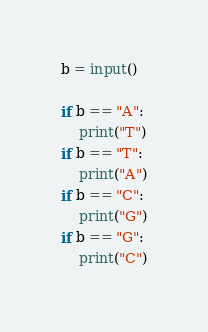<code> <loc_0><loc_0><loc_500><loc_500><_Python_>b = input()

if b == "A":
    print("T")
if b == "T":
    print("A")
if b == "C":
    print("G")
if b == "G":
    print("C")</code> 